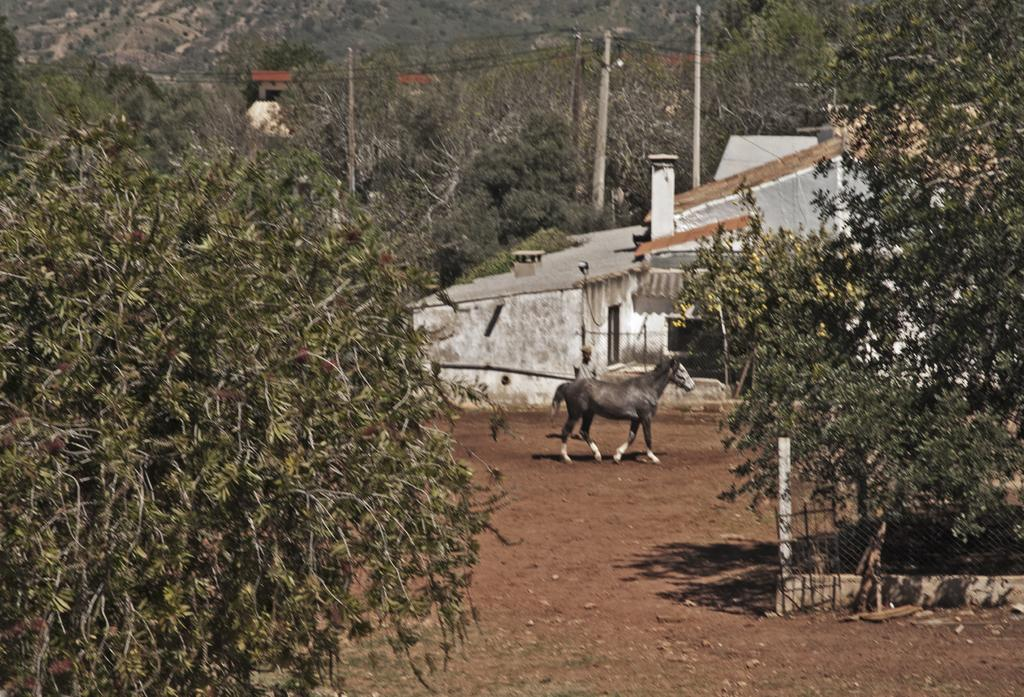What type of animal is in the image? There is an animal in the image, but the specific type cannot be determined from the provided facts. What is the person in the image doing? The provided facts do not mention the person's actions or activities. What can be seen on the ground in the image? The ground is visible in the image, but no specific details about the ground are mentioned. What type of vegetation is in the image? There are trees in the image, but no other types of vegetation are mentioned. What structures are in the image? There are poles and houses in the image. What else is present in the image? There are wires and a mesh in the image. How many ducks are visible in the image? There are no ducks present in the image. What is the duration of the minute shown in the image? There is no mention of a minute or any time-related element in the image. 